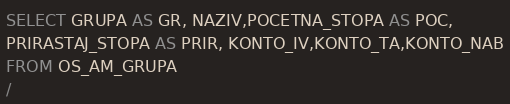<code> <loc_0><loc_0><loc_500><loc_500><_SQL_>SELECT GRUPA AS GR, NAZIV,POCETNA_STOPA AS POC,
PRIRASTAJ_STOPA AS PRIR, KONTO_IV,KONTO_TA,KONTO_NAB
FROM OS_AM_GRUPA
/
</code> 